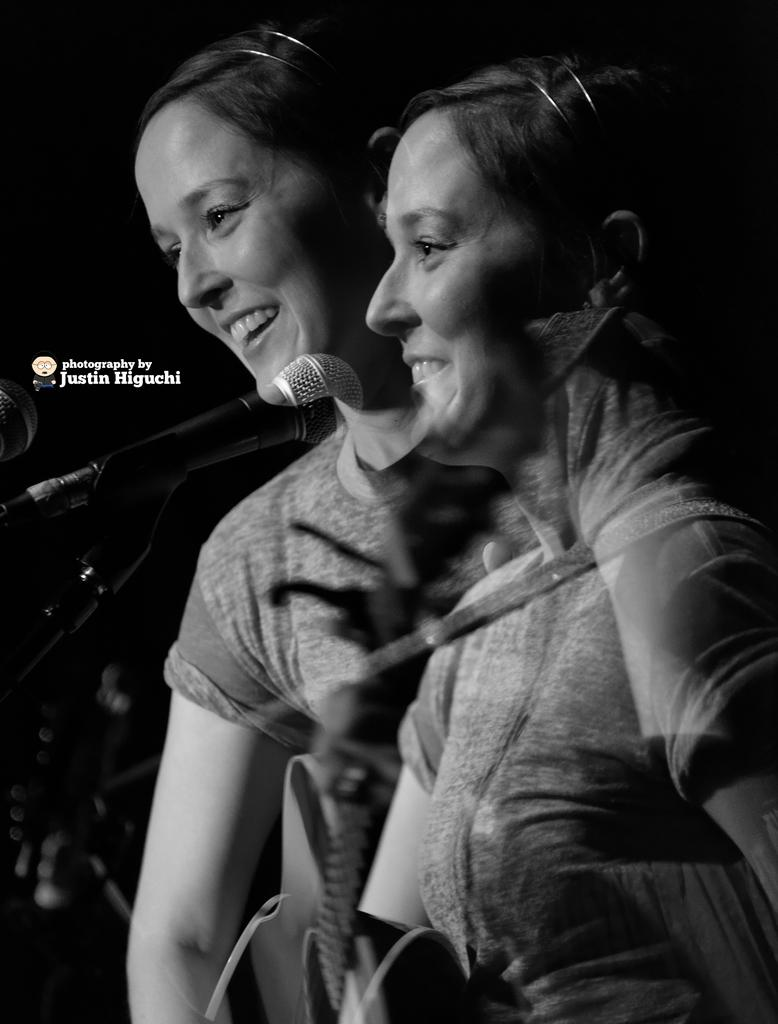What is the color scheme of the image? A: The image is black and white. How many people are in the image? There are two ladies in the image. What is the facial expression of the ladies? The ladies are smiling. What objects can be seen in the image? There are mics in the image. What is the background of the image like? The background of the image is dark. Is there any text present in the image? Yes, there is text written on the image. How many cacti are visible in the image? There are no cacti present in the image. What type of spoon is being used by the ladies in the image? There are no spoons visible in the image. 